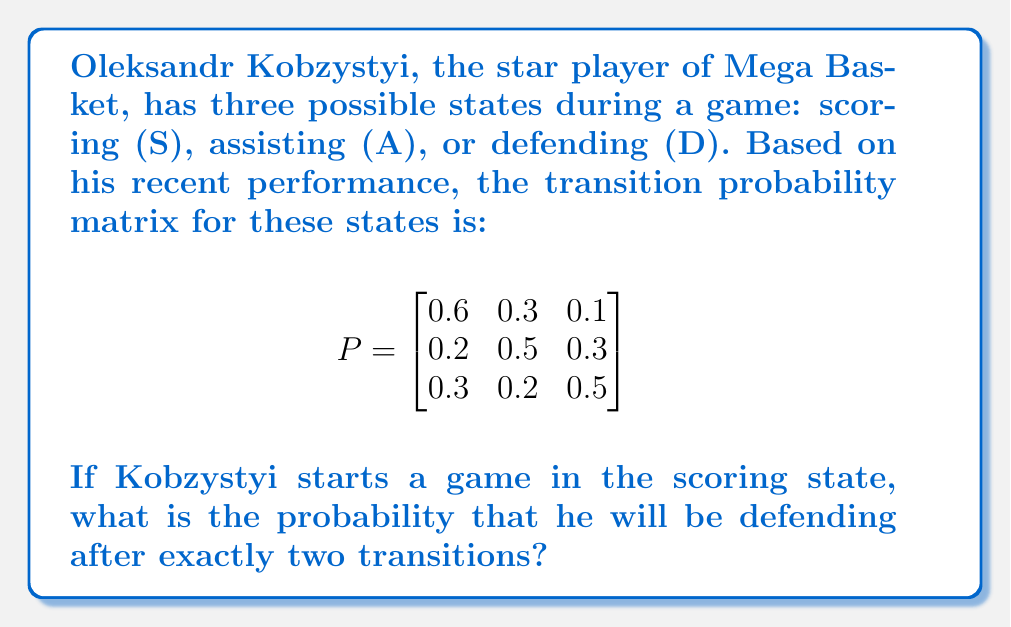Help me with this question. To solve this problem, we'll use the Markov chain matrix multiplication method:

1) First, we need to represent Kobzystyi's initial state as a vector. Since he starts in the scoring state, this vector is:

   $$v_0 = \begin{bmatrix} 1 & 0 & 0 \end{bmatrix}$$

2) To find the state after two transitions, we need to multiply this initial vector by the transition matrix P twice:

   $$v_2 = v_0 \cdot P^2$$

3) Let's calculate $P^2$:

   $$P^2 = P \cdot P = \begin{bmatrix}
   0.6 & 0.3 & 0.1 \\
   0.2 & 0.5 & 0.3 \\
   0.3 & 0.2 & 0.5
   \end{bmatrix} \cdot \begin{bmatrix}
   0.6 & 0.3 & 0.1 \\
   0.2 & 0.5 & 0.3 \\
   0.3 & 0.2 & 0.5
   \end{bmatrix}$$

4) Multiplying these matrices:

   $$P^2 = \begin{bmatrix}
   0.42 & 0.33 & 0.25 \\
   0.33 & 0.38 & 0.29 \\
   0.39 & 0.31 & 0.30
   \end{bmatrix}$$

5) Now, we multiply $v_0$ by $P^2$:

   $$v_2 = \begin{bmatrix} 1 & 0 & 0 \end{bmatrix} \cdot \begin{bmatrix}
   0.42 & 0.33 & 0.25 \\
   0.33 & 0.38 & 0.29 \\
   0.39 & 0.31 & 0.30
   \end{bmatrix} = \begin{bmatrix} 0.42 & 0.33 & 0.25 \end{bmatrix}$$

6) The probability of Kobzystyi being in the defending state (D) after two transitions is the third element of this resulting vector.
Answer: 0.25 